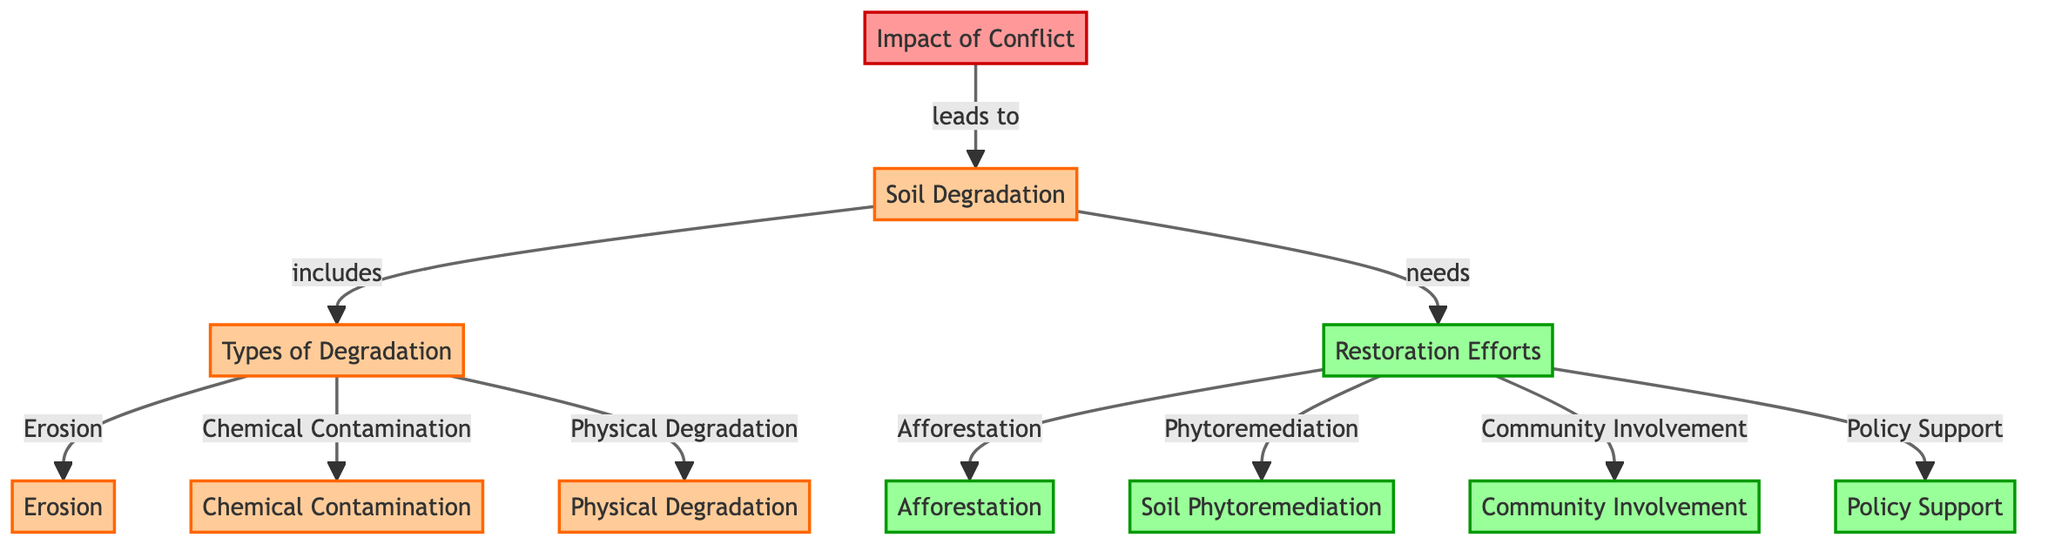What is the main impact of conflict as shown in the diagram? The diagram indicates that the main impact of conflict is "Soil Degradation" which is directly linked to "Impact of Conflict".
Answer: Soil Degradation How many types of soil degradation are depicted in the diagram? The diagram illustrates three distinct types of degradation: Erosion, Chemical Contamination, and Physical Degradation. Counting these types gives a total of three.
Answer: 3 Which restoration effort is associated with "Community Involvement"? According to the diagram, "Community Involvement" is one of the restoration efforts clearly listed under "Restoration Efforts".
Answer: Community Involvement What are the two specific restoration efforts mentioned in the diagram? The diagram outlines "Afforestation" and "Soil Phytoremediation" as specific restoration efforts linked under "Restoration Efforts". Therefore, these are the two mentioned efforts.
Answer: Afforestation, Soil Phytoremediation What leads to soil degradation in war-torn areas? The flow from "Impact of Conflict" to "Soil Degradation" indicates that the conflict itself is the leading cause of soil degradation in these areas.
Answer: Conflict How does soil degradation relate to restoration efforts? The diagram demonstrates that soil degradation creates a need for restoration efforts, as shown by the connection from "Soil Degradation" to "Restoration Efforts", indicating a direct relationship where degradation necessitates restoration.
Answer: Needs What is a direct result of soil degradation indicated in the diagram? The flow from "Soil Degradation" shows that it includes various types of degradation, hence, a direct result of soil degradation would be identified as either Erosion, Chemical Contamination, or Physical Degradation.
Answer: Erosion, Chemical Contamination, Physical Degradation Which type of degradation results from conflict according to the diagram? The diagram shows a direct transition from "Impact of Conflict" to "Soil Degradation", indicating that the type of degradation that results from conflict is represented under this category, which includes "Erosion", "Chemical Contamination", and "Physical Degradation".
Answer: Erosion, Chemical Contamination, Physical Degradation What restoration efforts are needed for addressing soil degradation in conflict areas? The diagram explicitly lists four restoration efforts required to address soil degradation: Afforestation, Soil Phytoremediation, Community Involvement, and Policy Support, all under the node "Restoration Efforts". These together indicate the necessary responses to combat degradation.
Answer: Afforestation, Soil Phytoremediation, Community Involvement, Policy Support 